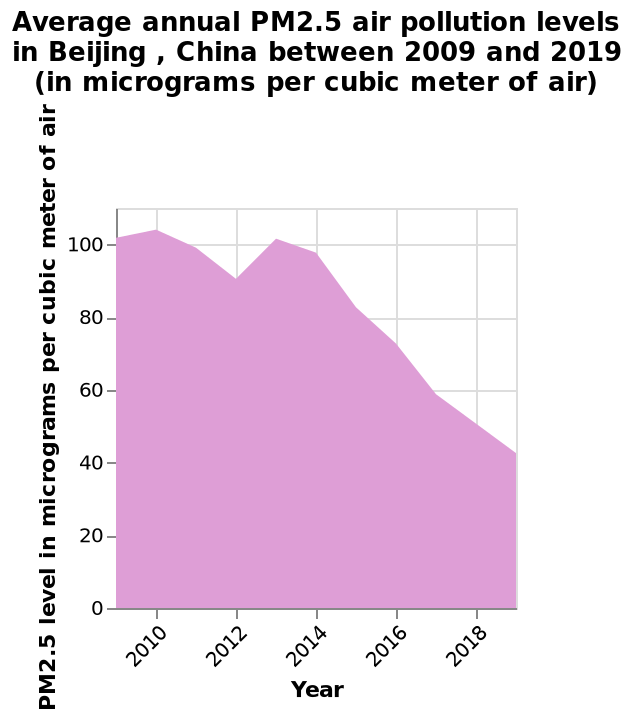<image>
What does the y-axis represent?  The y-axis represents the PM2.5 level in micrograms per cubic meter of air using a linear scale, ranging from 0 to 100. 